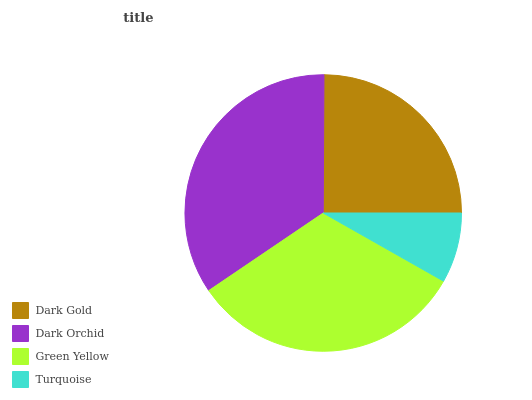Is Turquoise the minimum?
Answer yes or no. Yes. Is Dark Orchid the maximum?
Answer yes or no. Yes. Is Green Yellow the minimum?
Answer yes or no. No. Is Green Yellow the maximum?
Answer yes or no. No. Is Dark Orchid greater than Green Yellow?
Answer yes or no. Yes. Is Green Yellow less than Dark Orchid?
Answer yes or no. Yes. Is Green Yellow greater than Dark Orchid?
Answer yes or no. No. Is Dark Orchid less than Green Yellow?
Answer yes or no. No. Is Green Yellow the high median?
Answer yes or no. Yes. Is Dark Gold the low median?
Answer yes or no. Yes. Is Dark Orchid the high median?
Answer yes or no. No. Is Turquoise the low median?
Answer yes or no. No. 